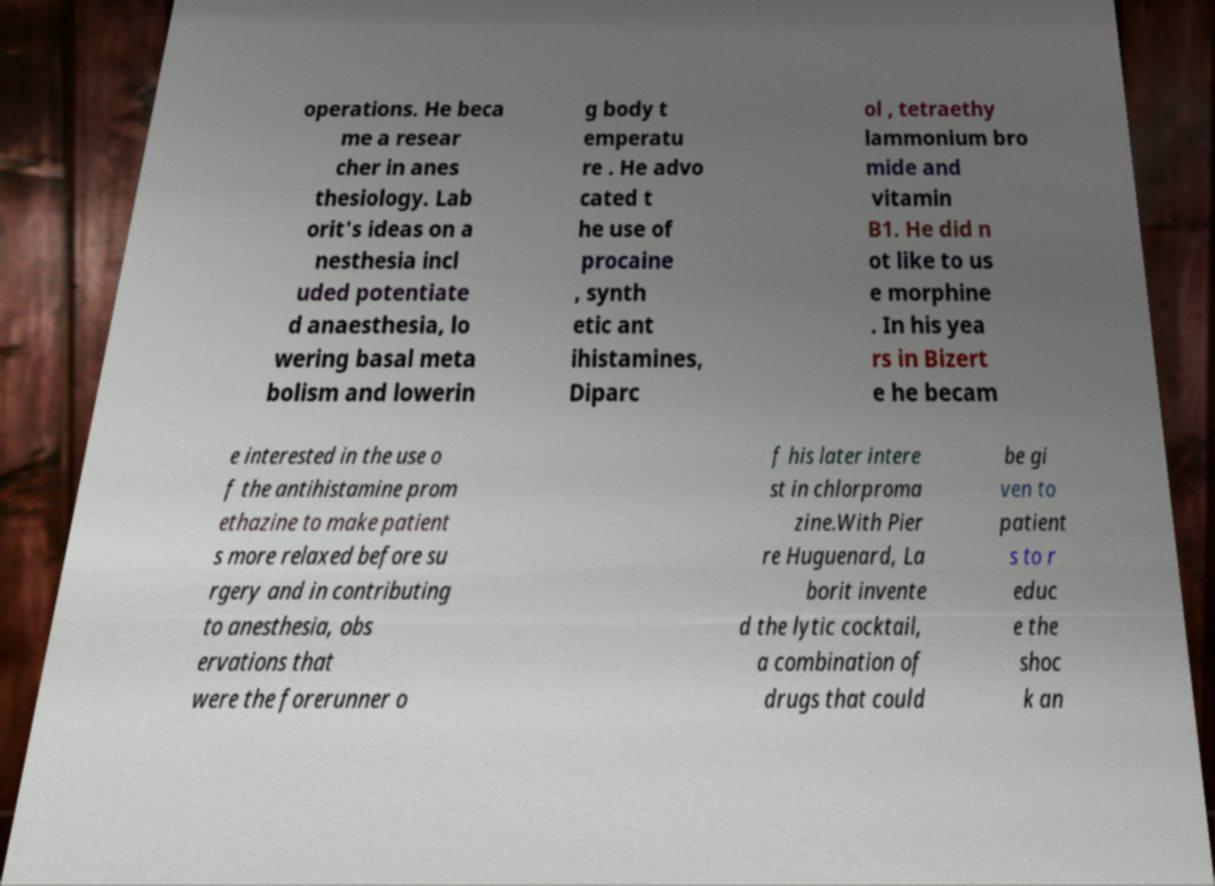Please read and relay the text visible in this image. What does it say? operations. He beca me a resear cher in anes thesiology. Lab orit's ideas on a nesthesia incl uded potentiate d anaesthesia, lo wering basal meta bolism and lowerin g body t emperatu re . He advo cated t he use of procaine , synth etic ant ihistamines, Diparc ol , tetraethy lammonium bro mide and vitamin B1. He did n ot like to us e morphine . In his yea rs in Bizert e he becam e interested in the use o f the antihistamine prom ethazine to make patient s more relaxed before su rgery and in contributing to anesthesia, obs ervations that were the forerunner o f his later intere st in chlorproma zine.With Pier re Huguenard, La borit invente d the lytic cocktail, a combination of drugs that could be gi ven to patient s to r educ e the shoc k an 